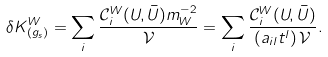Convert formula to latex. <formula><loc_0><loc_0><loc_500><loc_500>\delta K _ { ( g _ { s } ) } ^ { W } = \sum _ { i } \frac { \mathcal { C } _ { i } ^ { W } ( U , \bar { U } ) m _ { W } ^ { - 2 } } { \mathcal { V } } = \sum _ { i } \frac { \mathcal { C } _ { i } ^ { W } ( U , \bar { U } ) } { \left ( a _ { i l } t ^ { l } \right ) \mathcal { V } } .</formula> 